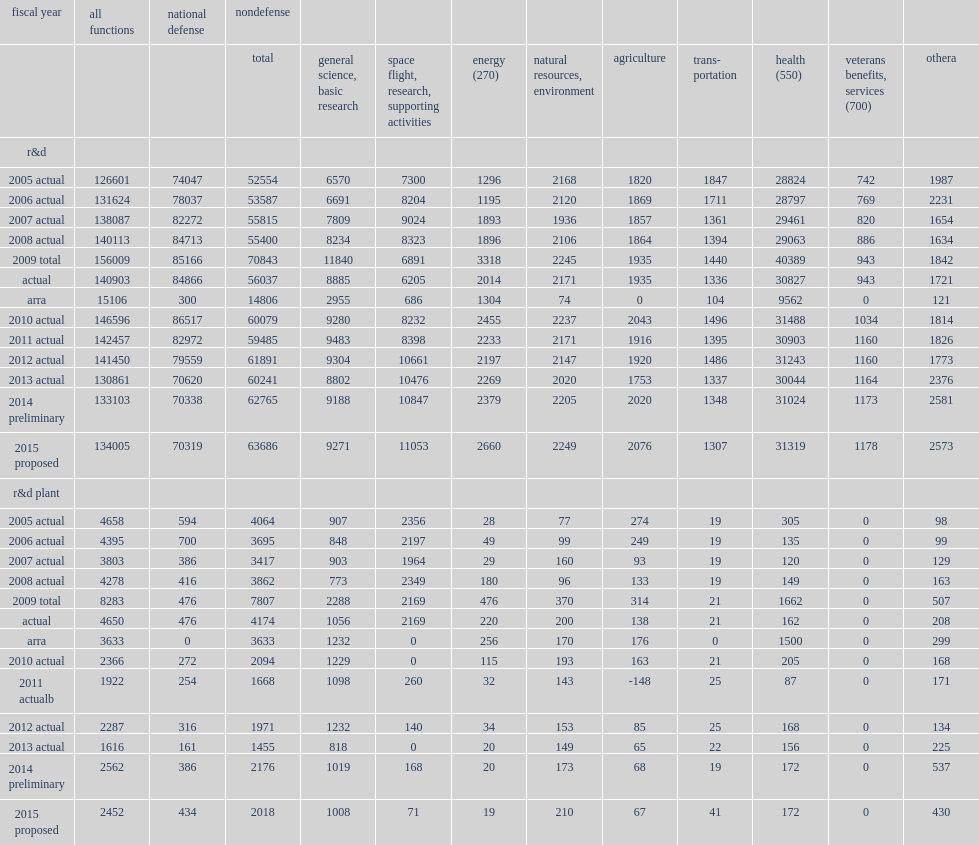How many million total for federal budget authority in fy 2013? 132477. How many million total for r&d in fy 2013? 130861.0. How many million total for r&d plant in fy 2013? 1616.0. How many million total for r&d in fy 2014? 133103.0. How many million total for r&d plant in fy 2014? 2562.0. How many million total for r&d in fy 2015? 134005.0. How many million total for r&d plant in fy 2015? 2452.0. 